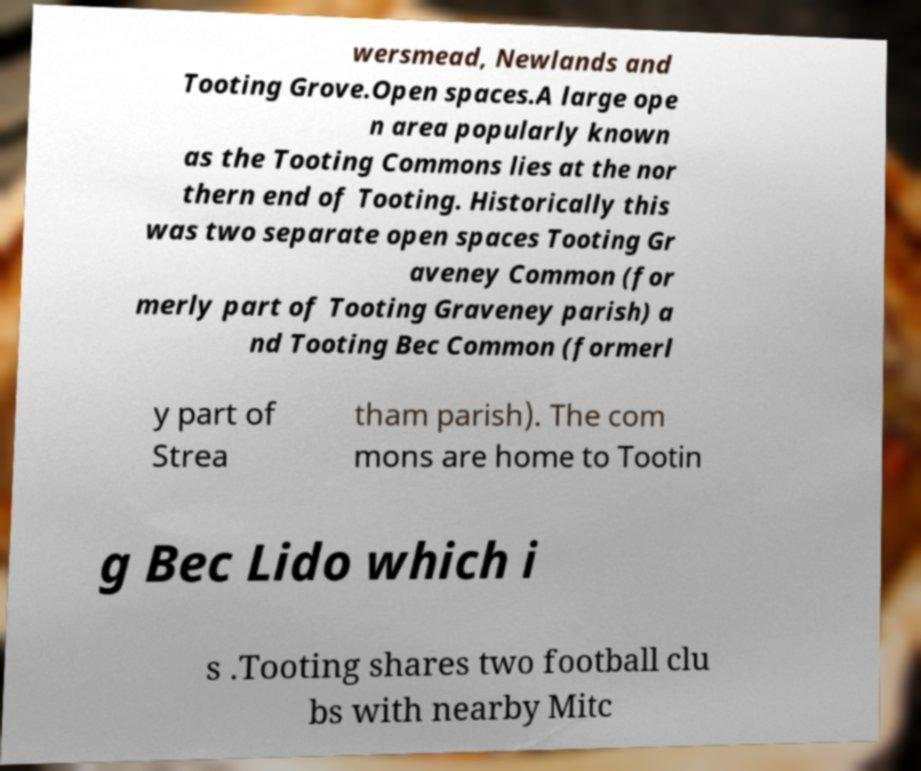What messages or text are displayed in this image? I need them in a readable, typed format. wersmead, Newlands and Tooting Grove.Open spaces.A large ope n area popularly known as the Tooting Commons lies at the nor thern end of Tooting. Historically this was two separate open spaces Tooting Gr aveney Common (for merly part of Tooting Graveney parish) a nd Tooting Bec Common (formerl y part of Strea tham parish). The com mons are home to Tootin g Bec Lido which i s .Tooting shares two football clu bs with nearby Mitc 